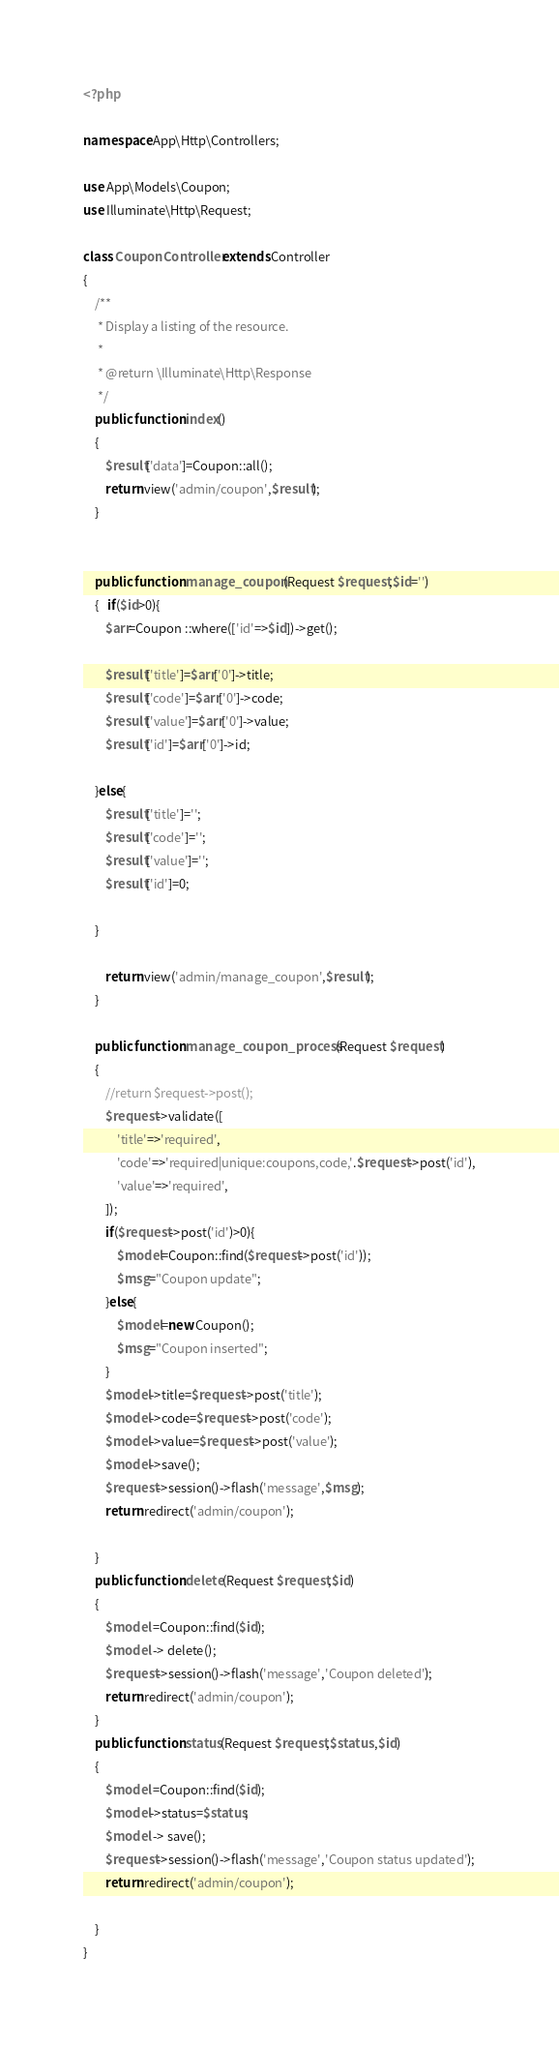<code> <loc_0><loc_0><loc_500><loc_500><_PHP_><?php

namespace App\Http\Controllers;

use App\Models\Coupon;
use Illuminate\Http\Request;

class CouponController extends Controller
{
    /**
     * Display a listing of the resource.
     *
     * @return \Illuminate\Http\Response
     */
    public function index()
    {   
        $result['data']=Coupon::all();
        return view('admin/coupon',$result);
    }

    
    public function manage_coupon(Request $request,$id='')
    {   if($id>0){
        $arr=Coupon ::where(['id'=>$id])->get();

        $result['title']=$arr['0']->title;
        $result['code']=$arr['0']->code;
        $result['value']=$arr['0']->value;
        $result['id']=$arr['0']->id;

    }else{
        $result['title']='';
        $result['code']='';
        $result['value']='';
        $result['id']=0;

    }
        
        return view('admin/manage_coupon',$result);
    }
    
    public function manage_coupon_process(Request $request)
    {
        //return $request->post();
        $request->validate([
            'title'=>'required',
            'code'=>'required|unique:coupons,code,'.$request->post('id'),
            'value'=>'required',
        ]);
        if($request->post('id')>0){
            $model=Coupon::find($request->post('id'));
            $msg="Coupon update";
        }else{
            $model=new Coupon();
            $msg="Coupon inserted";
        }
        $model->title=$request->post('title');
        $model->code=$request->post('code');
        $model->value=$request->post('value');
        $model->save();
        $request->session()->flash('message',$msg);
        return redirect('admin/coupon');
        
    }
    public function delete(Request $request,$id)
    {
        $model =Coupon::find($id);
        $model -> delete();
        $request->session()->flash('message','Coupon deleted');
        return redirect('admin/coupon');
    }
    public function status(Request $request,$status ,$id)
    {
        $model =Coupon::find($id);
        $model->status=$status;
        $model -> save();
        $request->session()->flash('message','Coupon status updated');
        return redirect('admin/coupon');
      
    }
}
</code> 